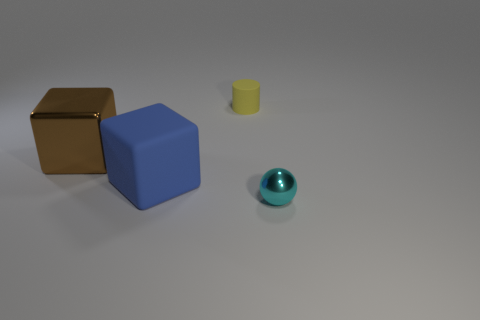Add 3 cylinders. How many objects exist? 7 Subtract all cylinders. How many objects are left? 3 Subtract all brown matte balls. Subtract all spheres. How many objects are left? 3 Add 1 big things. How many big things are left? 3 Add 1 small brown metallic cylinders. How many small brown metallic cylinders exist? 1 Subtract 0 green blocks. How many objects are left? 4 